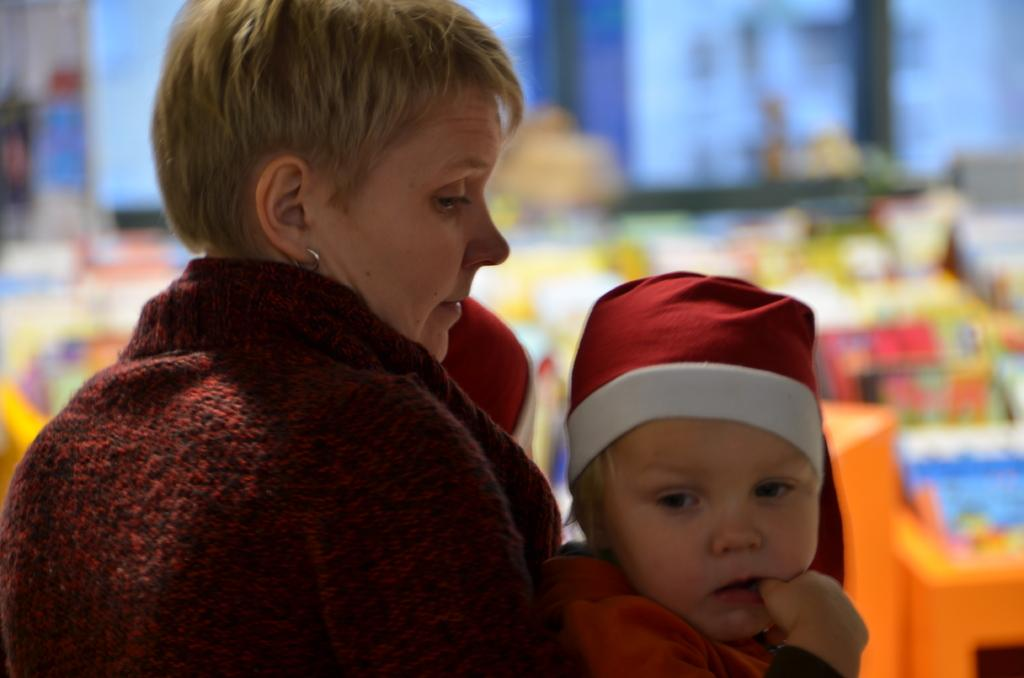Who is the main subject in the image? There is a woman in the image. What is the woman wearing? The woman is wearing a jacket. What is the woman doing in the image? The woman is holding a baby. What is the baby wearing? The baby is wearing a red and white colored dress. Can you describe the background of the image? The background of the image is blurry, and there are objects visible, although they are not clearly identifiable. What type of steel is used to make the flesh visible in the image? There is no steel or flesh present in the image. The image features a woman holding a baby, and the background is blurry with unidentifiable objects. 